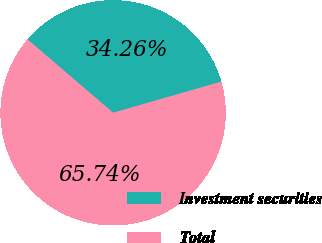Convert chart. <chart><loc_0><loc_0><loc_500><loc_500><pie_chart><fcel>Investment securities<fcel>Total<nl><fcel>34.26%<fcel>65.74%<nl></chart> 